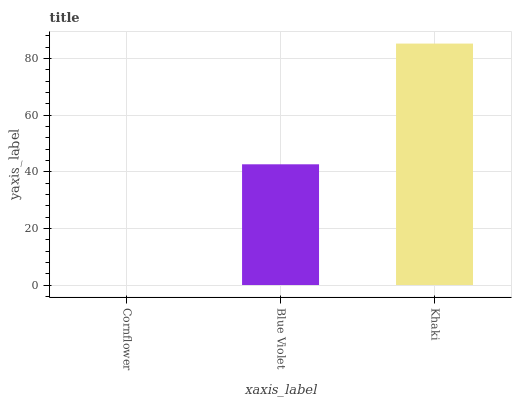Is Blue Violet the minimum?
Answer yes or no. No. Is Blue Violet the maximum?
Answer yes or no. No. Is Blue Violet greater than Cornflower?
Answer yes or no. Yes. Is Cornflower less than Blue Violet?
Answer yes or no. Yes. Is Cornflower greater than Blue Violet?
Answer yes or no. No. Is Blue Violet less than Cornflower?
Answer yes or no. No. Is Blue Violet the high median?
Answer yes or no. Yes. Is Blue Violet the low median?
Answer yes or no. Yes. Is Khaki the high median?
Answer yes or no. No. Is Khaki the low median?
Answer yes or no. No. 